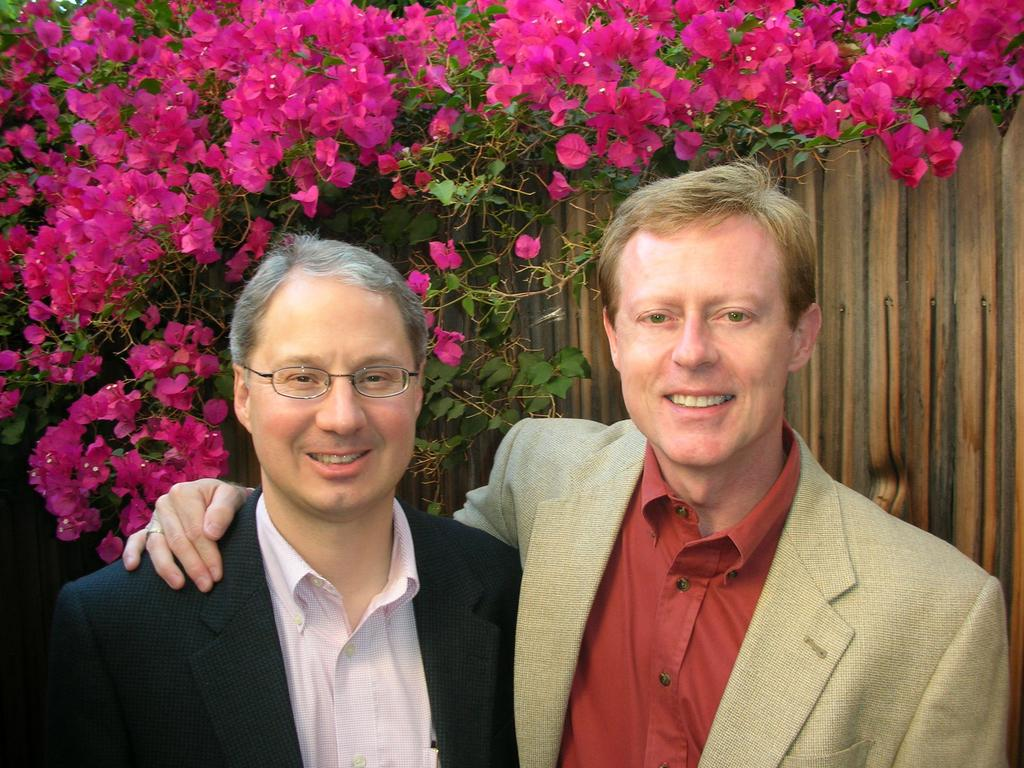How many people are in the image? There are two men in the image. What are the men wearing? The men are wearing suits. What can be seen in the background of the image? There are flowers and leaves in the background of the image. What type of structure is present in the image? There is a wooden fence in the image. How many rabbits can be seen hopping around near the wooden fence in the image? There are no rabbits present in the image; it only features two men in suits and a wooden fence. 